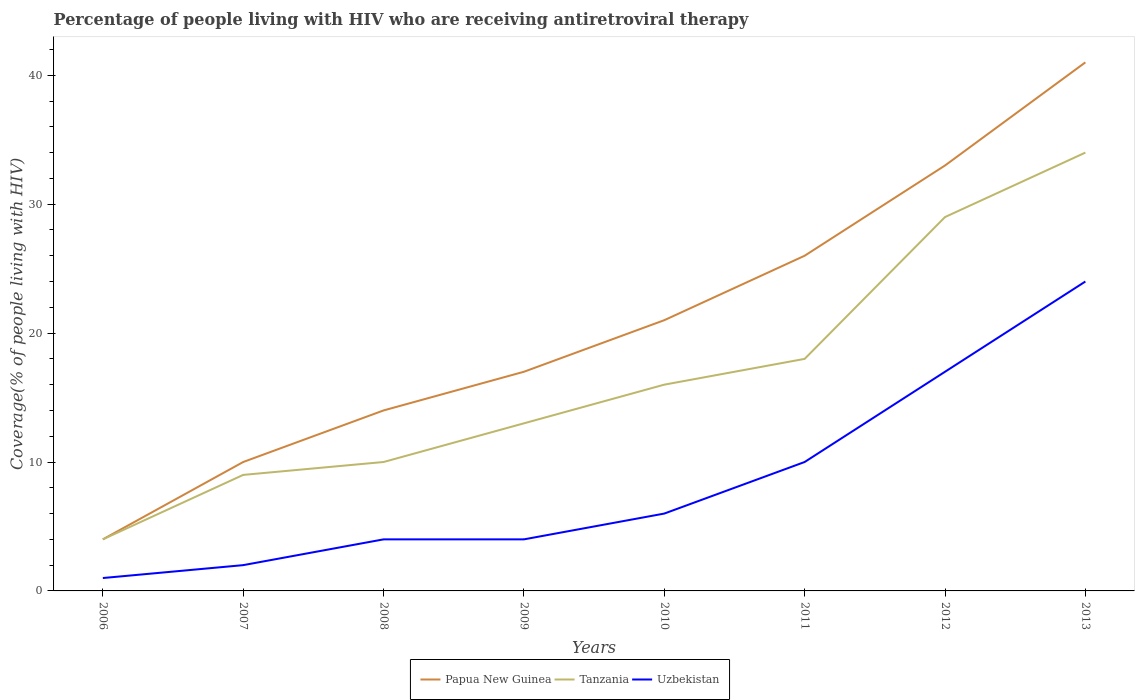How many different coloured lines are there?
Make the answer very short. 3. Is the number of lines equal to the number of legend labels?
Provide a short and direct response. Yes. Across all years, what is the maximum percentage of the HIV infected people who are receiving antiretroviral therapy in Papua New Guinea?
Ensure brevity in your answer.  4. What is the total percentage of the HIV infected people who are receiving antiretroviral therapy in Uzbekistan in the graph?
Give a very brief answer. -14. What is the difference between the highest and the second highest percentage of the HIV infected people who are receiving antiretroviral therapy in Papua New Guinea?
Your answer should be compact. 37. Is the percentage of the HIV infected people who are receiving antiretroviral therapy in Papua New Guinea strictly greater than the percentage of the HIV infected people who are receiving antiretroviral therapy in Uzbekistan over the years?
Keep it short and to the point. No. How many lines are there?
Provide a short and direct response. 3. What is the difference between two consecutive major ticks on the Y-axis?
Give a very brief answer. 10. Does the graph contain any zero values?
Ensure brevity in your answer.  No. Where does the legend appear in the graph?
Your answer should be compact. Bottom center. How many legend labels are there?
Make the answer very short. 3. How are the legend labels stacked?
Offer a terse response. Horizontal. What is the title of the graph?
Give a very brief answer. Percentage of people living with HIV who are receiving antiretroviral therapy. What is the label or title of the X-axis?
Provide a succinct answer. Years. What is the label or title of the Y-axis?
Your answer should be very brief. Coverage(% of people living with HIV). What is the Coverage(% of people living with HIV) in Uzbekistan in 2006?
Provide a short and direct response. 1. What is the Coverage(% of people living with HIV) in Papua New Guinea in 2007?
Your response must be concise. 10. What is the Coverage(% of people living with HIV) in Tanzania in 2007?
Offer a very short reply. 9. What is the Coverage(% of people living with HIV) of Uzbekistan in 2007?
Ensure brevity in your answer.  2. What is the Coverage(% of people living with HIV) in Papua New Guinea in 2009?
Make the answer very short. 17. What is the Coverage(% of people living with HIV) in Tanzania in 2009?
Provide a succinct answer. 13. What is the Coverage(% of people living with HIV) of Papua New Guinea in 2010?
Give a very brief answer. 21. What is the Coverage(% of people living with HIV) of Tanzania in 2011?
Your response must be concise. 18. What is the Coverage(% of people living with HIV) in Tanzania in 2012?
Provide a short and direct response. 29. What is the Coverage(% of people living with HIV) in Tanzania in 2013?
Your response must be concise. 34. What is the total Coverage(% of people living with HIV) in Papua New Guinea in the graph?
Offer a terse response. 166. What is the total Coverage(% of people living with HIV) of Tanzania in the graph?
Offer a terse response. 133. What is the difference between the Coverage(% of people living with HIV) of Tanzania in 2006 and that in 2007?
Your answer should be compact. -5. What is the difference between the Coverage(% of people living with HIV) of Papua New Guinea in 2006 and that in 2008?
Offer a very short reply. -10. What is the difference between the Coverage(% of people living with HIV) of Uzbekistan in 2006 and that in 2009?
Provide a succinct answer. -3. What is the difference between the Coverage(% of people living with HIV) of Papua New Guinea in 2006 and that in 2010?
Give a very brief answer. -17. What is the difference between the Coverage(% of people living with HIV) in Tanzania in 2006 and that in 2011?
Provide a short and direct response. -14. What is the difference between the Coverage(% of people living with HIV) of Papua New Guinea in 2006 and that in 2012?
Offer a very short reply. -29. What is the difference between the Coverage(% of people living with HIV) of Tanzania in 2006 and that in 2012?
Your response must be concise. -25. What is the difference between the Coverage(% of people living with HIV) of Uzbekistan in 2006 and that in 2012?
Your answer should be compact. -16. What is the difference between the Coverage(% of people living with HIV) of Papua New Guinea in 2006 and that in 2013?
Provide a short and direct response. -37. What is the difference between the Coverage(% of people living with HIV) of Uzbekistan in 2006 and that in 2013?
Ensure brevity in your answer.  -23. What is the difference between the Coverage(% of people living with HIV) in Tanzania in 2007 and that in 2008?
Keep it short and to the point. -1. What is the difference between the Coverage(% of people living with HIV) in Uzbekistan in 2007 and that in 2008?
Provide a succinct answer. -2. What is the difference between the Coverage(% of people living with HIV) in Tanzania in 2007 and that in 2009?
Ensure brevity in your answer.  -4. What is the difference between the Coverage(% of people living with HIV) of Uzbekistan in 2007 and that in 2009?
Keep it short and to the point. -2. What is the difference between the Coverage(% of people living with HIV) of Papua New Guinea in 2007 and that in 2010?
Make the answer very short. -11. What is the difference between the Coverage(% of people living with HIV) in Uzbekistan in 2007 and that in 2011?
Your answer should be very brief. -8. What is the difference between the Coverage(% of people living with HIV) of Papua New Guinea in 2007 and that in 2013?
Offer a very short reply. -31. What is the difference between the Coverage(% of people living with HIV) of Tanzania in 2007 and that in 2013?
Make the answer very short. -25. What is the difference between the Coverage(% of people living with HIV) in Tanzania in 2008 and that in 2009?
Provide a short and direct response. -3. What is the difference between the Coverage(% of people living with HIV) of Uzbekistan in 2008 and that in 2009?
Make the answer very short. 0. What is the difference between the Coverage(% of people living with HIV) in Tanzania in 2008 and that in 2010?
Your answer should be compact. -6. What is the difference between the Coverage(% of people living with HIV) in Uzbekistan in 2008 and that in 2010?
Make the answer very short. -2. What is the difference between the Coverage(% of people living with HIV) in Uzbekistan in 2008 and that in 2011?
Your answer should be compact. -6. What is the difference between the Coverage(% of people living with HIV) of Uzbekistan in 2008 and that in 2012?
Keep it short and to the point. -13. What is the difference between the Coverage(% of people living with HIV) in Tanzania in 2008 and that in 2013?
Offer a very short reply. -24. What is the difference between the Coverage(% of people living with HIV) in Tanzania in 2009 and that in 2010?
Keep it short and to the point. -3. What is the difference between the Coverage(% of people living with HIV) in Uzbekistan in 2009 and that in 2011?
Your response must be concise. -6. What is the difference between the Coverage(% of people living with HIV) in Tanzania in 2009 and that in 2012?
Provide a succinct answer. -16. What is the difference between the Coverage(% of people living with HIV) in Uzbekistan in 2010 and that in 2011?
Keep it short and to the point. -4. What is the difference between the Coverage(% of people living with HIV) in Papua New Guinea in 2010 and that in 2012?
Keep it short and to the point. -12. What is the difference between the Coverage(% of people living with HIV) of Uzbekistan in 2010 and that in 2012?
Offer a terse response. -11. What is the difference between the Coverage(% of people living with HIV) in Papua New Guinea in 2010 and that in 2013?
Make the answer very short. -20. What is the difference between the Coverage(% of people living with HIV) in Tanzania in 2010 and that in 2013?
Keep it short and to the point. -18. What is the difference between the Coverage(% of people living with HIV) in Papua New Guinea in 2011 and that in 2012?
Your answer should be very brief. -7. What is the difference between the Coverage(% of people living with HIV) in Tanzania in 2011 and that in 2012?
Provide a short and direct response. -11. What is the difference between the Coverage(% of people living with HIV) of Uzbekistan in 2011 and that in 2012?
Offer a terse response. -7. What is the difference between the Coverage(% of people living with HIV) of Tanzania in 2011 and that in 2013?
Give a very brief answer. -16. What is the difference between the Coverage(% of people living with HIV) in Papua New Guinea in 2012 and that in 2013?
Keep it short and to the point. -8. What is the difference between the Coverage(% of people living with HIV) in Uzbekistan in 2012 and that in 2013?
Offer a very short reply. -7. What is the difference between the Coverage(% of people living with HIV) of Papua New Guinea in 2006 and the Coverage(% of people living with HIV) of Tanzania in 2007?
Your answer should be very brief. -5. What is the difference between the Coverage(% of people living with HIV) of Tanzania in 2006 and the Coverage(% of people living with HIV) of Uzbekistan in 2007?
Offer a very short reply. 2. What is the difference between the Coverage(% of people living with HIV) in Papua New Guinea in 2006 and the Coverage(% of people living with HIV) in Tanzania in 2008?
Your answer should be very brief. -6. What is the difference between the Coverage(% of people living with HIV) of Papua New Guinea in 2006 and the Coverage(% of people living with HIV) of Uzbekistan in 2008?
Offer a terse response. 0. What is the difference between the Coverage(% of people living with HIV) in Papua New Guinea in 2006 and the Coverage(% of people living with HIV) in Uzbekistan in 2009?
Offer a terse response. 0. What is the difference between the Coverage(% of people living with HIV) of Tanzania in 2006 and the Coverage(% of people living with HIV) of Uzbekistan in 2009?
Provide a succinct answer. 0. What is the difference between the Coverage(% of people living with HIV) in Tanzania in 2006 and the Coverage(% of people living with HIV) in Uzbekistan in 2012?
Offer a very short reply. -13. What is the difference between the Coverage(% of people living with HIV) in Papua New Guinea in 2006 and the Coverage(% of people living with HIV) in Uzbekistan in 2013?
Provide a succinct answer. -20. What is the difference between the Coverage(% of people living with HIV) in Tanzania in 2006 and the Coverage(% of people living with HIV) in Uzbekistan in 2013?
Provide a succinct answer. -20. What is the difference between the Coverage(% of people living with HIV) in Papua New Guinea in 2007 and the Coverage(% of people living with HIV) in Tanzania in 2008?
Provide a short and direct response. 0. What is the difference between the Coverage(% of people living with HIV) of Papua New Guinea in 2007 and the Coverage(% of people living with HIV) of Uzbekistan in 2008?
Offer a very short reply. 6. What is the difference between the Coverage(% of people living with HIV) in Papua New Guinea in 2007 and the Coverage(% of people living with HIV) in Tanzania in 2009?
Your response must be concise. -3. What is the difference between the Coverage(% of people living with HIV) in Papua New Guinea in 2007 and the Coverage(% of people living with HIV) in Uzbekistan in 2009?
Give a very brief answer. 6. What is the difference between the Coverage(% of people living with HIV) of Tanzania in 2007 and the Coverage(% of people living with HIV) of Uzbekistan in 2009?
Provide a short and direct response. 5. What is the difference between the Coverage(% of people living with HIV) of Papua New Guinea in 2007 and the Coverage(% of people living with HIV) of Uzbekistan in 2010?
Give a very brief answer. 4. What is the difference between the Coverage(% of people living with HIV) of Papua New Guinea in 2007 and the Coverage(% of people living with HIV) of Tanzania in 2011?
Keep it short and to the point. -8. What is the difference between the Coverage(% of people living with HIV) in Papua New Guinea in 2007 and the Coverage(% of people living with HIV) in Uzbekistan in 2011?
Your answer should be very brief. 0. What is the difference between the Coverage(% of people living with HIV) in Papua New Guinea in 2007 and the Coverage(% of people living with HIV) in Uzbekistan in 2012?
Your response must be concise. -7. What is the difference between the Coverage(% of people living with HIV) in Papua New Guinea in 2007 and the Coverage(% of people living with HIV) in Tanzania in 2013?
Offer a terse response. -24. What is the difference between the Coverage(% of people living with HIV) of Tanzania in 2007 and the Coverage(% of people living with HIV) of Uzbekistan in 2013?
Your answer should be compact. -15. What is the difference between the Coverage(% of people living with HIV) in Papua New Guinea in 2008 and the Coverage(% of people living with HIV) in Tanzania in 2009?
Make the answer very short. 1. What is the difference between the Coverage(% of people living with HIV) of Tanzania in 2008 and the Coverage(% of people living with HIV) of Uzbekistan in 2009?
Your answer should be very brief. 6. What is the difference between the Coverage(% of people living with HIV) in Papua New Guinea in 2008 and the Coverage(% of people living with HIV) in Tanzania in 2010?
Keep it short and to the point. -2. What is the difference between the Coverage(% of people living with HIV) of Papua New Guinea in 2008 and the Coverage(% of people living with HIV) of Uzbekistan in 2010?
Provide a succinct answer. 8. What is the difference between the Coverage(% of people living with HIV) of Tanzania in 2008 and the Coverage(% of people living with HIV) of Uzbekistan in 2010?
Your response must be concise. 4. What is the difference between the Coverage(% of people living with HIV) of Papua New Guinea in 2008 and the Coverage(% of people living with HIV) of Tanzania in 2011?
Offer a terse response. -4. What is the difference between the Coverage(% of people living with HIV) in Papua New Guinea in 2008 and the Coverage(% of people living with HIV) in Uzbekistan in 2011?
Provide a short and direct response. 4. What is the difference between the Coverage(% of people living with HIV) of Papua New Guinea in 2008 and the Coverage(% of people living with HIV) of Uzbekistan in 2012?
Keep it short and to the point. -3. What is the difference between the Coverage(% of people living with HIV) of Papua New Guinea in 2008 and the Coverage(% of people living with HIV) of Uzbekistan in 2013?
Offer a very short reply. -10. What is the difference between the Coverage(% of people living with HIV) in Papua New Guinea in 2009 and the Coverage(% of people living with HIV) in Uzbekistan in 2010?
Your response must be concise. 11. What is the difference between the Coverage(% of people living with HIV) of Tanzania in 2009 and the Coverage(% of people living with HIV) of Uzbekistan in 2011?
Ensure brevity in your answer.  3. What is the difference between the Coverage(% of people living with HIV) in Papua New Guinea in 2009 and the Coverage(% of people living with HIV) in Uzbekistan in 2012?
Offer a terse response. 0. What is the difference between the Coverage(% of people living with HIV) of Papua New Guinea in 2009 and the Coverage(% of people living with HIV) of Tanzania in 2013?
Offer a very short reply. -17. What is the difference between the Coverage(% of people living with HIV) of Papua New Guinea in 2009 and the Coverage(% of people living with HIV) of Uzbekistan in 2013?
Your answer should be compact. -7. What is the difference between the Coverage(% of people living with HIV) of Tanzania in 2009 and the Coverage(% of people living with HIV) of Uzbekistan in 2013?
Make the answer very short. -11. What is the difference between the Coverage(% of people living with HIV) of Papua New Guinea in 2010 and the Coverage(% of people living with HIV) of Uzbekistan in 2011?
Offer a very short reply. 11. What is the difference between the Coverage(% of people living with HIV) in Tanzania in 2010 and the Coverage(% of people living with HIV) in Uzbekistan in 2011?
Provide a succinct answer. 6. What is the difference between the Coverage(% of people living with HIV) in Papua New Guinea in 2010 and the Coverage(% of people living with HIV) in Tanzania in 2012?
Offer a very short reply. -8. What is the difference between the Coverage(% of people living with HIV) in Papua New Guinea in 2010 and the Coverage(% of people living with HIV) in Uzbekistan in 2012?
Provide a succinct answer. 4. What is the difference between the Coverage(% of people living with HIV) in Tanzania in 2010 and the Coverage(% of people living with HIV) in Uzbekistan in 2012?
Your response must be concise. -1. What is the difference between the Coverage(% of people living with HIV) of Papua New Guinea in 2010 and the Coverage(% of people living with HIV) of Tanzania in 2013?
Give a very brief answer. -13. What is the difference between the Coverage(% of people living with HIV) in Tanzania in 2010 and the Coverage(% of people living with HIV) in Uzbekistan in 2013?
Provide a succinct answer. -8. What is the difference between the Coverage(% of people living with HIV) of Papua New Guinea in 2011 and the Coverage(% of people living with HIV) of Uzbekistan in 2012?
Your response must be concise. 9. What is the difference between the Coverage(% of people living with HIV) of Tanzania in 2011 and the Coverage(% of people living with HIV) of Uzbekistan in 2012?
Your answer should be very brief. 1. What is the difference between the Coverage(% of people living with HIV) in Papua New Guinea in 2011 and the Coverage(% of people living with HIV) in Tanzania in 2013?
Your answer should be compact. -8. What is the difference between the Coverage(% of people living with HIV) in Papua New Guinea in 2011 and the Coverage(% of people living with HIV) in Uzbekistan in 2013?
Make the answer very short. 2. What is the difference between the Coverage(% of people living with HIV) in Tanzania in 2011 and the Coverage(% of people living with HIV) in Uzbekistan in 2013?
Ensure brevity in your answer.  -6. What is the difference between the Coverage(% of people living with HIV) in Papua New Guinea in 2012 and the Coverage(% of people living with HIV) in Tanzania in 2013?
Offer a terse response. -1. What is the difference between the Coverage(% of people living with HIV) in Papua New Guinea in 2012 and the Coverage(% of people living with HIV) in Uzbekistan in 2013?
Provide a short and direct response. 9. What is the average Coverage(% of people living with HIV) of Papua New Guinea per year?
Offer a very short reply. 20.75. What is the average Coverage(% of people living with HIV) in Tanzania per year?
Ensure brevity in your answer.  16.62. What is the average Coverage(% of people living with HIV) of Uzbekistan per year?
Your answer should be very brief. 8.5. In the year 2006, what is the difference between the Coverage(% of people living with HIV) of Papua New Guinea and Coverage(% of people living with HIV) of Tanzania?
Your response must be concise. 0. In the year 2006, what is the difference between the Coverage(% of people living with HIV) in Papua New Guinea and Coverage(% of people living with HIV) in Uzbekistan?
Make the answer very short. 3. In the year 2007, what is the difference between the Coverage(% of people living with HIV) in Papua New Guinea and Coverage(% of people living with HIV) in Uzbekistan?
Provide a succinct answer. 8. In the year 2008, what is the difference between the Coverage(% of people living with HIV) of Papua New Guinea and Coverage(% of people living with HIV) of Tanzania?
Your answer should be very brief. 4. In the year 2009, what is the difference between the Coverage(% of people living with HIV) in Papua New Guinea and Coverage(% of people living with HIV) in Tanzania?
Your answer should be compact. 4. In the year 2009, what is the difference between the Coverage(% of people living with HIV) of Papua New Guinea and Coverage(% of people living with HIV) of Uzbekistan?
Give a very brief answer. 13. In the year 2011, what is the difference between the Coverage(% of people living with HIV) in Tanzania and Coverage(% of people living with HIV) in Uzbekistan?
Provide a succinct answer. 8. In the year 2012, what is the difference between the Coverage(% of people living with HIV) in Papua New Guinea and Coverage(% of people living with HIV) in Tanzania?
Provide a short and direct response. 4. In the year 2012, what is the difference between the Coverage(% of people living with HIV) in Papua New Guinea and Coverage(% of people living with HIV) in Uzbekistan?
Keep it short and to the point. 16. In the year 2012, what is the difference between the Coverage(% of people living with HIV) in Tanzania and Coverage(% of people living with HIV) in Uzbekistan?
Your answer should be compact. 12. In the year 2013, what is the difference between the Coverage(% of people living with HIV) in Papua New Guinea and Coverage(% of people living with HIV) in Tanzania?
Provide a short and direct response. 7. In the year 2013, what is the difference between the Coverage(% of people living with HIV) in Papua New Guinea and Coverage(% of people living with HIV) in Uzbekistan?
Your response must be concise. 17. What is the ratio of the Coverage(% of people living with HIV) of Papua New Guinea in 2006 to that in 2007?
Offer a very short reply. 0.4. What is the ratio of the Coverage(% of people living with HIV) in Tanzania in 2006 to that in 2007?
Offer a terse response. 0.44. What is the ratio of the Coverage(% of people living with HIV) of Papua New Guinea in 2006 to that in 2008?
Give a very brief answer. 0.29. What is the ratio of the Coverage(% of people living with HIV) in Tanzania in 2006 to that in 2008?
Give a very brief answer. 0.4. What is the ratio of the Coverage(% of people living with HIV) in Papua New Guinea in 2006 to that in 2009?
Make the answer very short. 0.24. What is the ratio of the Coverage(% of people living with HIV) in Tanzania in 2006 to that in 2009?
Offer a terse response. 0.31. What is the ratio of the Coverage(% of people living with HIV) of Uzbekistan in 2006 to that in 2009?
Give a very brief answer. 0.25. What is the ratio of the Coverage(% of people living with HIV) in Papua New Guinea in 2006 to that in 2010?
Your answer should be very brief. 0.19. What is the ratio of the Coverage(% of people living with HIV) of Uzbekistan in 2006 to that in 2010?
Give a very brief answer. 0.17. What is the ratio of the Coverage(% of people living with HIV) of Papua New Guinea in 2006 to that in 2011?
Give a very brief answer. 0.15. What is the ratio of the Coverage(% of people living with HIV) in Tanzania in 2006 to that in 2011?
Provide a short and direct response. 0.22. What is the ratio of the Coverage(% of people living with HIV) of Papua New Guinea in 2006 to that in 2012?
Give a very brief answer. 0.12. What is the ratio of the Coverage(% of people living with HIV) in Tanzania in 2006 to that in 2012?
Ensure brevity in your answer.  0.14. What is the ratio of the Coverage(% of people living with HIV) in Uzbekistan in 2006 to that in 2012?
Provide a succinct answer. 0.06. What is the ratio of the Coverage(% of people living with HIV) in Papua New Guinea in 2006 to that in 2013?
Keep it short and to the point. 0.1. What is the ratio of the Coverage(% of people living with HIV) in Tanzania in 2006 to that in 2013?
Your answer should be compact. 0.12. What is the ratio of the Coverage(% of people living with HIV) of Uzbekistan in 2006 to that in 2013?
Offer a very short reply. 0.04. What is the ratio of the Coverage(% of people living with HIV) of Papua New Guinea in 2007 to that in 2009?
Your answer should be very brief. 0.59. What is the ratio of the Coverage(% of people living with HIV) of Tanzania in 2007 to that in 2009?
Provide a succinct answer. 0.69. What is the ratio of the Coverage(% of people living with HIV) of Uzbekistan in 2007 to that in 2009?
Offer a very short reply. 0.5. What is the ratio of the Coverage(% of people living with HIV) of Papua New Guinea in 2007 to that in 2010?
Ensure brevity in your answer.  0.48. What is the ratio of the Coverage(% of people living with HIV) in Tanzania in 2007 to that in 2010?
Your response must be concise. 0.56. What is the ratio of the Coverage(% of people living with HIV) of Uzbekistan in 2007 to that in 2010?
Give a very brief answer. 0.33. What is the ratio of the Coverage(% of people living with HIV) of Papua New Guinea in 2007 to that in 2011?
Your answer should be compact. 0.38. What is the ratio of the Coverage(% of people living with HIV) of Papua New Guinea in 2007 to that in 2012?
Keep it short and to the point. 0.3. What is the ratio of the Coverage(% of people living with HIV) in Tanzania in 2007 to that in 2012?
Your answer should be compact. 0.31. What is the ratio of the Coverage(% of people living with HIV) of Uzbekistan in 2007 to that in 2012?
Provide a short and direct response. 0.12. What is the ratio of the Coverage(% of people living with HIV) in Papua New Guinea in 2007 to that in 2013?
Your response must be concise. 0.24. What is the ratio of the Coverage(% of people living with HIV) in Tanzania in 2007 to that in 2013?
Keep it short and to the point. 0.26. What is the ratio of the Coverage(% of people living with HIV) in Uzbekistan in 2007 to that in 2013?
Your response must be concise. 0.08. What is the ratio of the Coverage(% of people living with HIV) in Papua New Guinea in 2008 to that in 2009?
Provide a succinct answer. 0.82. What is the ratio of the Coverage(% of people living with HIV) of Tanzania in 2008 to that in 2009?
Your response must be concise. 0.77. What is the ratio of the Coverage(% of people living with HIV) in Tanzania in 2008 to that in 2010?
Offer a terse response. 0.62. What is the ratio of the Coverage(% of people living with HIV) of Uzbekistan in 2008 to that in 2010?
Offer a very short reply. 0.67. What is the ratio of the Coverage(% of people living with HIV) in Papua New Guinea in 2008 to that in 2011?
Provide a succinct answer. 0.54. What is the ratio of the Coverage(% of people living with HIV) in Tanzania in 2008 to that in 2011?
Provide a succinct answer. 0.56. What is the ratio of the Coverage(% of people living with HIV) in Uzbekistan in 2008 to that in 2011?
Offer a very short reply. 0.4. What is the ratio of the Coverage(% of people living with HIV) in Papua New Guinea in 2008 to that in 2012?
Offer a terse response. 0.42. What is the ratio of the Coverage(% of people living with HIV) of Tanzania in 2008 to that in 2012?
Offer a very short reply. 0.34. What is the ratio of the Coverage(% of people living with HIV) of Uzbekistan in 2008 to that in 2012?
Offer a terse response. 0.24. What is the ratio of the Coverage(% of people living with HIV) in Papua New Guinea in 2008 to that in 2013?
Provide a short and direct response. 0.34. What is the ratio of the Coverage(% of people living with HIV) in Tanzania in 2008 to that in 2013?
Give a very brief answer. 0.29. What is the ratio of the Coverage(% of people living with HIV) in Uzbekistan in 2008 to that in 2013?
Ensure brevity in your answer.  0.17. What is the ratio of the Coverage(% of people living with HIV) in Papua New Guinea in 2009 to that in 2010?
Your answer should be compact. 0.81. What is the ratio of the Coverage(% of people living with HIV) in Tanzania in 2009 to that in 2010?
Make the answer very short. 0.81. What is the ratio of the Coverage(% of people living with HIV) in Papua New Guinea in 2009 to that in 2011?
Offer a very short reply. 0.65. What is the ratio of the Coverage(% of people living with HIV) in Tanzania in 2009 to that in 2011?
Provide a succinct answer. 0.72. What is the ratio of the Coverage(% of people living with HIV) of Papua New Guinea in 2009 to that in 2012?
Your response must be concise. 0.52. What is the ratio of the Coverage(% of people living with HIV) in Tanzania in 2009 to that in 2012?
Offer a terse response. 0.45. What is the ratio of the Coverage(% of people living with HIV) in Uzbekistan in 2009 to that in 2012?
Your response must be concise. 0.24. What is the ratio of the Coverage(% of people living with HIV) of Papua New Guinea in 2009 to that in 2013?
Ensure brevity in your answer.  0.41. What is the ratio of the Coverage(% of people living with HIV) in Tanzania in 2009 to that in 2013?
Ensure brevity in your answer.  0.38. What is the ratio of the Coverage(% of people living with HIV) in Papua New Guinea in 2010 to that in 2011?
Keep it short and to the point. 0.81. What is the ratio of the Coverage(% of people living with HIV) of Uzbekistan in 2010 to that in 2011?
Ensure brevity in your answer.  0.6. What is the ratio of the Coverage(% of people living with HIV) of Papua New Guinea in 2010 to that in 2012?
Provide a succinct answer. 0.64. What is the ratio of the Coverage(% of people living with HIV) in Tanzania in 2010 to that in 2012?
Keep it short and to the point. 0.55. What is the ratio of the Coverage(% of people living with HIV) of Uzbekistan in 2010 to that in 2012?
Your answer should be compact. 0.35. What is the ratio of the Coverage(% of people living with HIV) in Papua New Guinea in 2010 to that in 2013?
Make the answer very short. 0.51. What is the ratio of the Coverage(% of people living with HIV) of Tanzania in 2010 to that in 2013?
Provide a short and direct response. 0.47. What is the ratio of the Coverage(% of people living with HIV) in Papua New Guinea in 2011 to that in 2012?
Give a very brief answer. 0.79. What is the ratio of the Coverage(% of people living with HIV) of Tanzania in 2011 to that in 2012?
Your answer should be very brief. 0.62. What is the ratio of the Coverage(% of people living with HIV) of Uzbekistan in 2011 to that in 2012?
Your answer should be very brief. 0.59. What is the ratio of the Coverage(% of people living with HIV) in Papua New Guinea in 2011 to that in 2013?
Offer a very short reply. 0.63. What is the ratio of the Coverage(% of people living with HIV) of Tanzania in 2011 to that in 2013?
Ensure brevity in your answer.  0.53. What is the ratio of the Coverage(% of people living with HIV) in Uzbekistan in 2011 to that in 2013?
Offer a very short reply. 0.42. What is the ratio of the Coverage(% of people living with HIV) in Papua New Guinea in 2012 to that in 2013?
Your response must be concise. 0.8. What is the ratio of the Coverage(% of people living with HIV) of Tanzania in 2012 to that in 2013?
Provide a short and direct response. 0.85. What is the ratio of the Coverage(% of people living with HIV) in Uzbekistan in 2012 to that in 2013?
Your answer should be very brief. 0.71. What is the difference between the highest and the second highest Coverage(% of people living with HIV) of Papua New Guinea?
Your answer should be compact. 8. What is the difference between the highest and the second highest Coverage(% of people living with HIV) of Tanzania?
Provide a succinct answer. 5. What is the difference between the highest and the lowest Coverage(% of people living with HIV) of Tanzania?
Your answer should be very brief. 30. What is the difference between the highest and the lowest Coverage(% of people living with HIV) of Uzbekistan?
Provide a succinct answer. 23. 